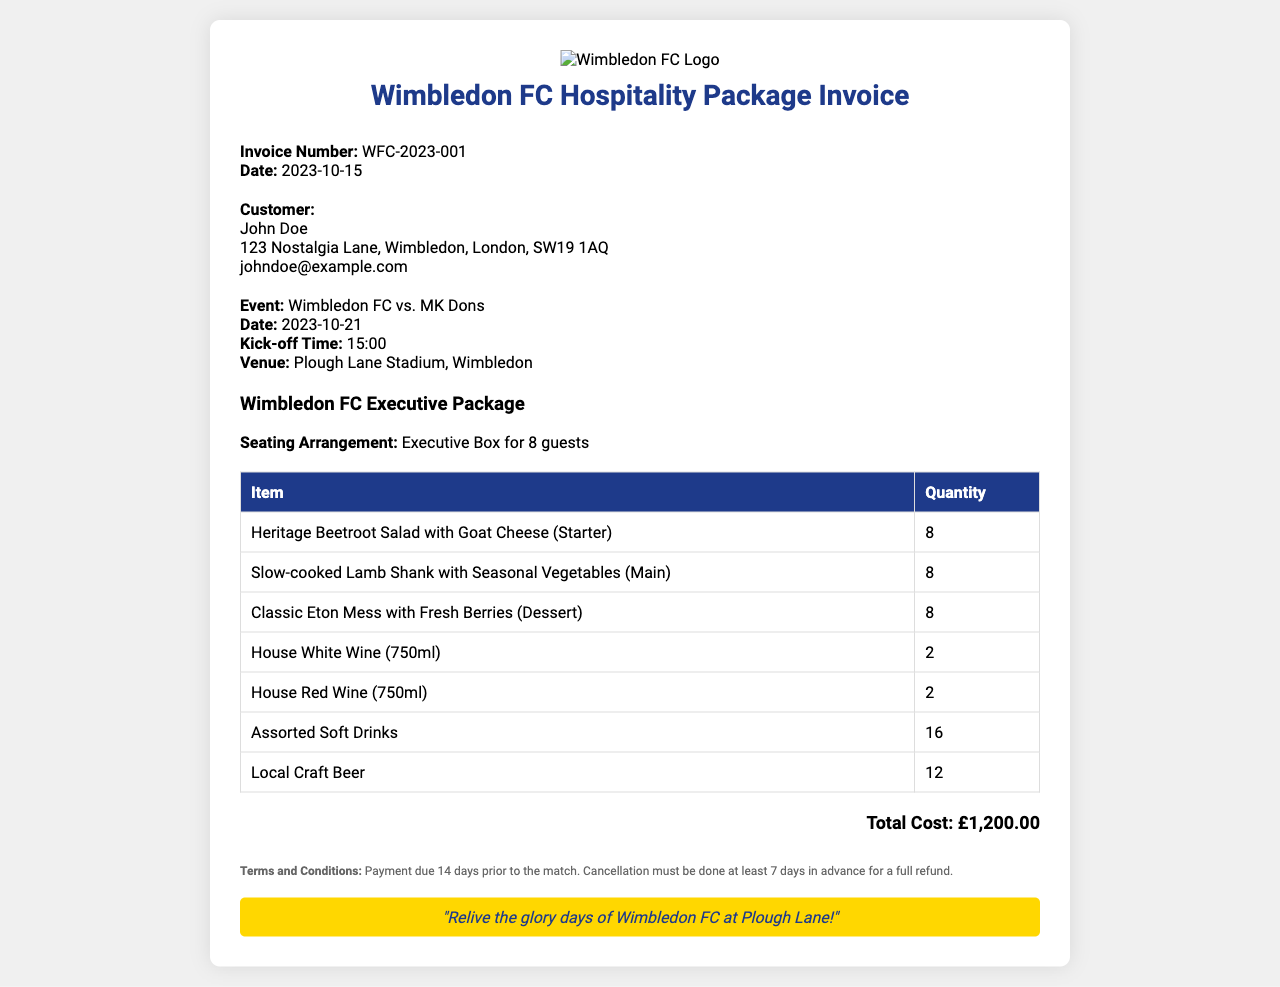What is the invoice number? The invoice number is a unique identifier for this transaction, which can be found in the invoice details section.
Answer: WFC-2023-001 What is the customer's email? The customer's email address is listed under the customer details section.
Answer: johndoe@example.com What date is the event scheduled for? The event date can be found in the event details section of the invoice.
Answer: 2023-10-21 How many guests can be accommodated in the executive box? The seating arrangement specifies the number of guests that the executive box can hold.
Answer: 8 guests What is the total cost of the hospitality package? The total cost is highlighted at the bottom of the invoice, reflecting the overall amount due.
Answer: £1,200.00 What is the main course offered in the package? The main course is specified in the table of food items, listing the available dishes for the hospitality package.
Answer: Slow-cooked Lamb Shank with Seasonal Vegetables How many bottles of house red wine are included? The quantity of house red wine is noted in the table where drinks are listed.
Answer: 2 What is the venue for the match? The venue is mentioned in the event details section of the document.
Answer: Plough Lane Stadium, Wimbledon What is the cancellation policy? The cancellation policy details are provided towards the end of the invoice under terms and conditions.
Answer: 7 days in advance for a full refund 